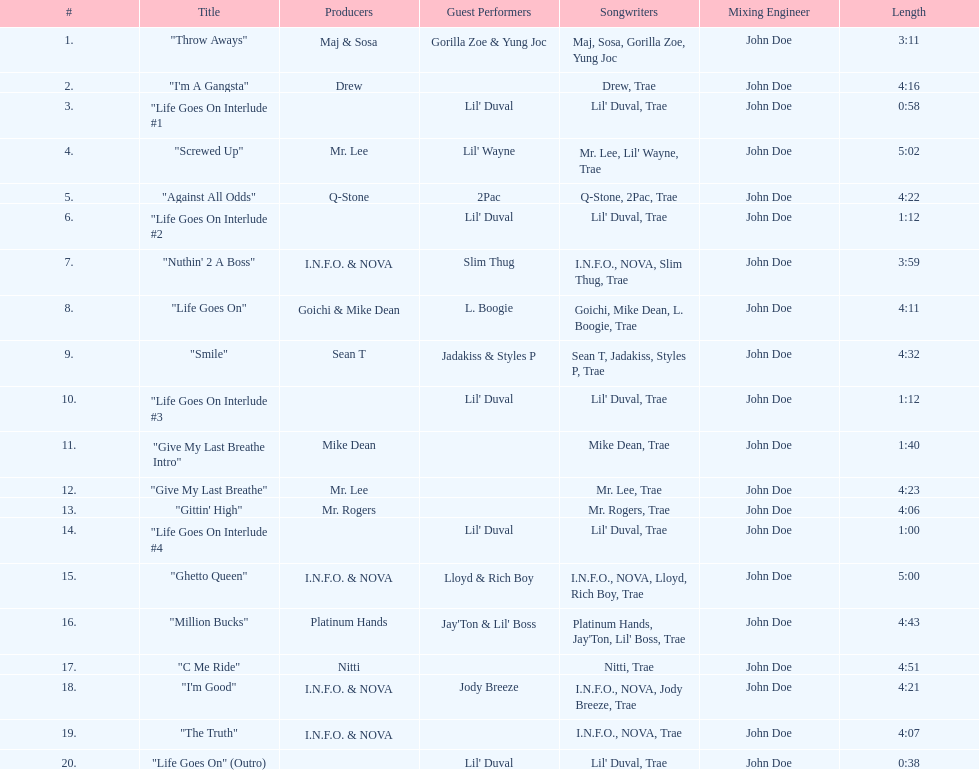Which producers produced the majority of songs on this record? I.N.F.O. & NOVA. Parse the table in full. {'header': ['#', 'Title', 'Producers', 'Guest Performers', 'Songwriters', 'Mixing Engineer', 'Length'], 'rows': [['1.', '"Throw Aways"', 'Maj & Sosa', 'Gorilla Zoe & Yung Joc', 'Maj, Sosa, Gorilla Zoe, Yung Joc', 'John Doe', '3:11'], ['2.', '"I\'m A Gangsta"', 'Drew', '', 'Drew, Trae', 'John Doe', '4:16'], ['3.', '"Life Goes On Interlude #1', '', "Lil' Duval", "Lil' Duval, Trae", 'John Doe', '0:58'], ['4.', '"Screwed Up"', 'Mr. Lee', "Lil' Wayne", "Mr. Lee, Lil' Wayne, Trae", 'John Doe', '5:02'], ['5.', '"Against All Odds"', 'Q-Stone', '2Pac', 'Q-Stone, 2Pac, Trae', 'John Doe', '4:22'], ['6.', '"Life Goes On Interlude #2', '', "Lil' Duval", "Lil' Duval, Trae", 'John Doe', '1:12'], ['7.', '"Nuthin\' 2 A Boss"', 'I.N.F.O. & NOVA', 'Slim Thug', 'I.N.F.O., NOVA, Slim Thug, Trae', 'John Doe', '3:59'], ['8.', '"Life Goes On"', 'Goichi & Mike Dean', 'L. Boogie', 'Goichi, Mike Dean, L. Boogie, Trae', 'John Doe', '4:11'], ['9.', '"Smile"', 'Sean T', 'Jadakiss & Styles P', 'Sean T, Jadakiss, Styles P, Trae', 'John Doe', '4:32'], ['10.', '"Life Goes On Interlude #3', '', "Lil' Duval", "Lil' Duval, Trae", 'John Doe', '1:12'], ['11.', '"Give My Last Breathe Intro"', 'Mike Dean', '', 'Mike Dean, Trae', 'John Doe', '1:40'], ['12.', '"Give My Last Breathe"', 'Mr. Lee', '', 'Mr. Lee, Trae', 'John Doe', '4:23'], ['13.', '"Gittin\' High"', 'Mr. Rogers', '', 'Mr. Rogers, Trae', 'John Doe', '4:06'], ['14.', '"Life Goes On Interlude #4', '', "Lil' Duval", "Lil' Duval, Trae", 'John Doe', '1:00'], ['15.', '"Ghetto Queen"', 'I.N.F.O. & NOVA', 'Lloyd & Rich Boy', 'I.N.F.O., NOVA, Lloyd, Rich Boy, Trae', 'John Doe', '5:00'], ['16.', '"Million Bucks"', 'Platinum Hands', "Jay'Ton & Lil' Boss", "Platinum Hands, Jay'Ton, Lil' Boss, Trae", 'John Doe', '4:43'], ['17.', '"C Me Ride"', 'Nitti', '', 'Nitti, Trae', 'John Doe', '4:51'], ['18.', '"I\'m Good"', 'I.N.F.O. & NOVA', 'Jody Breeze', 'I.N.F.O., NOVA, Jody Breeze, Trae', 'John Doe', '4:21'], ['19.', '"The Truth"', 'I.N.F.O. & NOVA', '', 'I.N.F.O., NOVA, Trae', 'John Doe', '4:07'], ['20.', '"Life Goes On" (Outro)', '', "Lil' Duval", "Lil' Duval, Trae", 'John Doe', '0:38']]} 